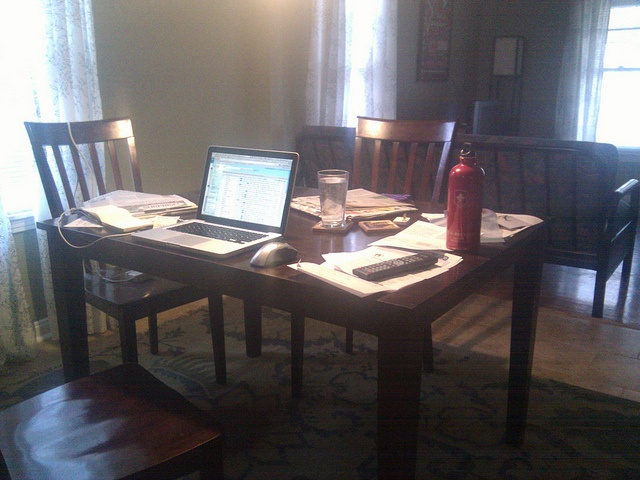Describe the objects in this image and their specific colors. I can see dining table in white, black, gray, and purple tones, chair in white, black, and gray tones, couch in white, gray, black, and blue tones, chair in white, black, gray, and purple tones, and laptop in white, gray, lightblue, and darkgray tones in this image. 